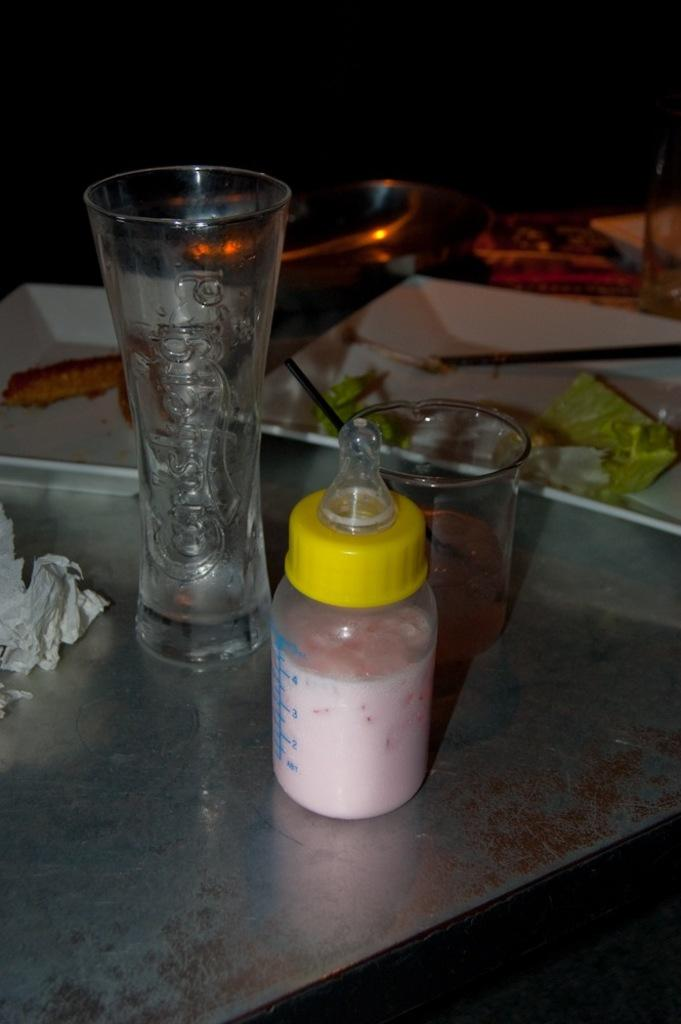What type of furniture is in the image? There is a table in the image. What is placed on the table? A baby sipper, glasses, and plates are present on the table. Can you see any fairies arguing over the yoke in the image? There are no fairies or yokes present in the image. 